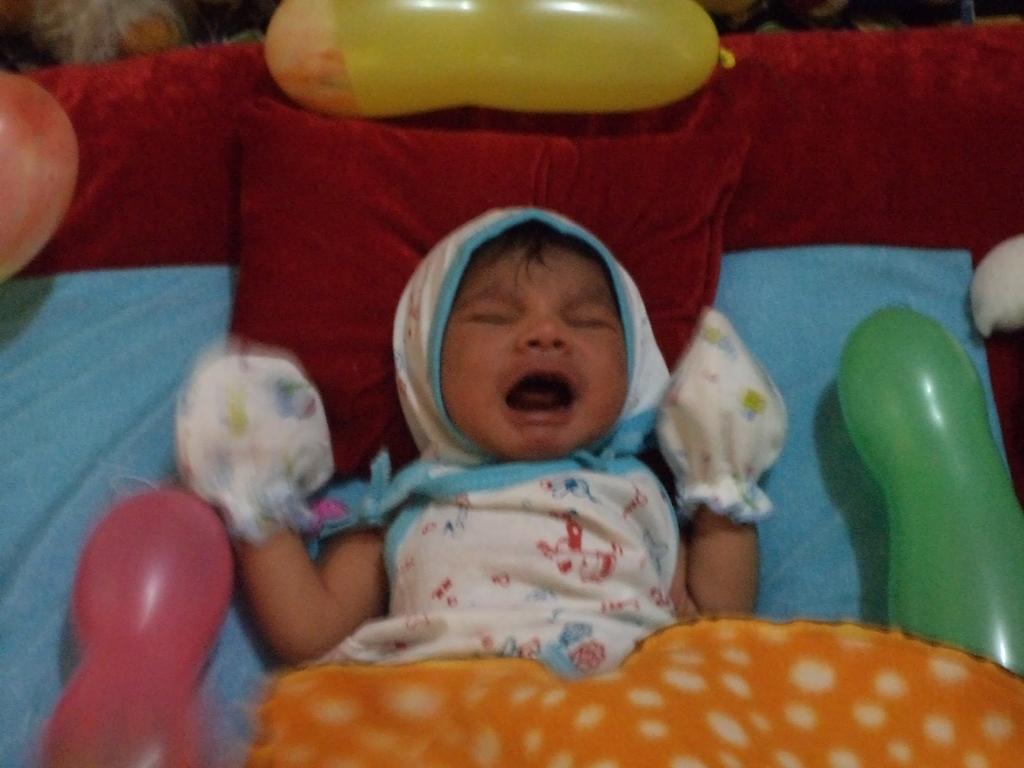How would you summarize this image in a sentence or two? In this image I can see a bed and on it I can see few red cushions, few balloons, an orange colour cloth and a baby. I can see this baby is wearing white and blue colour dress. 